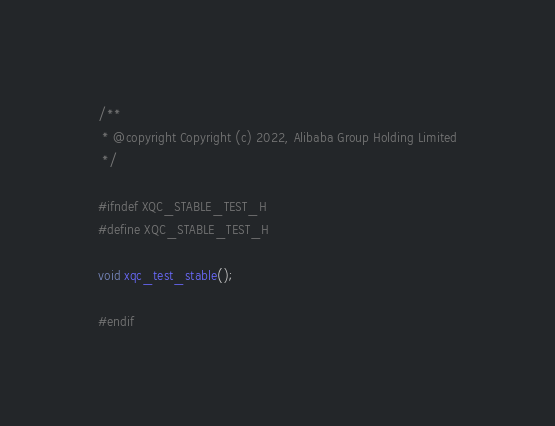Convert code to text. <code><loc_0><loc_0><loc_500><loc_500><_C_>/**
 * @copyright Copyright (c) 2022, Alibaba Group Holding Limited
 */

#ifndef XQC_STABLE_TEST_H
#define XQC_STABLE_TEST_H

void xqc_test_stable();

#endif
</code> 